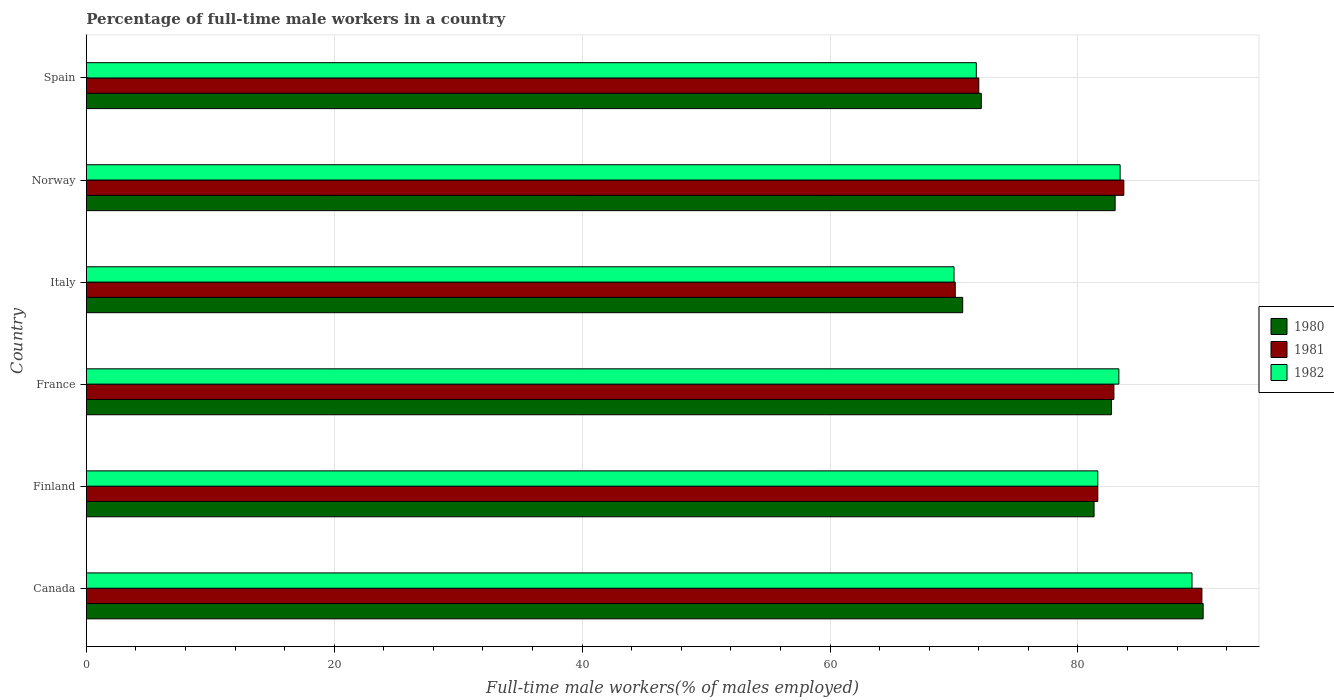How many different coloured bars are there?
Your answer should be very brief. 3. How many groups of bars are there?
Provide a short and direct response. 6. Are the number of bars per tick equal to the number of legend labels?
Provide a short and direct response. Yes. Are the number of bars on each tick of the Y-axis equal?
Offer a terse response. Yes. How many bars are there on the 2nd tick from the top?
Your response must be concise. 3. How many bars are there on the 4th tick from the bottom?
Your response must be concise. 3. What is the label of the 4th group of bars from the top?
Offer a very short reply. France. What is the percentage of full-time male workers in 1981 in France?
Make the answer very short. 82.9. Across all countries, what is the maximum percentage of full-time male workers in 1980?
Provide a short and direct response. 90.1. Across all countries, what is the minimum percentage of full-time male workers in 1980?
Provide a short and direct response. 70.7. In which country was the percentage of full-time male workers in 1982 minimum?
Ensure brevity in your answer.  Italy. What is the total percentage of full-time male workers in 1982 in the graph?
Your response must be concise. 479.3. What is the difference between the percentage of full-time male workers in 1980 in Canada and that in Spain?
Your answer should be compact. 17.9. What is the difference between the percentage of full-time male workers in 1981 in Norway and the percentage of full-time male workers in 1980 in Finland?
Ensure brevity in your answer.  2.4. What is the average percentage of full-time male workers in 1981 per country?
Offer a terse response. 80.05. What is the difference between the percentage of full-time male workers in 1982 and percentage of full-time male workers in 1980 in Spain?
Offer a very short reply. -0.4. What is the ratio of the percentage of full-time male workers in 1981 in France to that in Norway?
Your answer should be compact. 0.99. Is the percentage of full-time male workers in 1982 in Canada less than that in Finland?
Keep it short and to the point. No. What is the difference between the highest and the second highest percentage of full-time male workers in 1981?
Provide a short and direct response. 6.3. What is the difference between the highest and the lowest percentage of full-time male workers in 1982?
Your answer should be very brief. 19.2. In how many countries, is the percentage of full-time male workers in 1980 greater than the average percentage of full-time male workers in 1980 taken over all countries?
Your response must be concise. 4. Is the sum of the percentage of full-time male workers in 1980 in Finland and Spain greater than the maximum percentage of full-time male workers in 1982 across all countries?
Provide a succinct answer. Yes. What does the 3rd bar from the top in Italy represents?
Ensure brevity in your answer.  1980. What does the 2nd bar from the bottom in Italy represents?
Keep it short and to the point. 1981. Are all the bars in the graph horizontal?
Ensure brevity in your answer.  Yes. What is the difference between two consecutive major ticks on the X-axis?
Offer a terse response. 20. Are the values on the major ticks of X-axis written in scientific E-notation?
Your answer should be very brief. No. Where does the legend appear in the graph?
Your response must be concise. Center right. How many legend labels are there?
Your answer should be very brief. 3. How are the legend labels stacked?
Ensure brevity in your answer.  Vertical. What is the title of the graph?
Offer a very short reply. Percentage of full-time male workers in a country. Does "1987" appear as one of the legend labels in the graph?
Give a very brief answer. No. What is the label or title of the X-axis?
Keep it short and to the point. Full-time male workers(% of males employed). What is the Full-time male workers(% of males employed) in 1980 in Canada?
Your answer should be very brief. 90.1. What is the Full-time male workers(% of males employed) of 1982 in Canada?
Provide a succinct answer. 89.2. What is the Full-time male workers(% of males employed) of 1980 in Finland?
Offer a very short reply. 81.3. What is the Full-time male workers(% of males employed) in 1981 in Finland?
Provide a short and direct response. 81.6. What is the Full-time male workers(% of males employed) of 1982 in Finland?
Your response must be concise. 81.6. What is the Full-time male workers(% of males employed) of 1980 in France?
Offer a very short reply. 82.7. What is the Full-time male workers(% of males employed) in 1981 in France?
Offer a very short reply. 82.9. What is the Full-time male workers(% of males employed) of 1982 in France?
Offer a very short reply. 83.3. What is the Full-time male workers(% of males employed) of 1980 in Italy?
Provide a succinct answer. 70.7. What is the Full-time male workers(% of males employed) of 1981 in Italy?
Ensure brevity in your answer.  70.1. What is the Full-time male workers(% of males employed) in 1980 in Norway?
Offer a terse response. 83. What is the Full-time male workers(% of males employed) of 1981 in Norway?
Provide a succinct answer. 83.7. What is the Full-time male workers(% of males employed) in 1982 in Norway?
Your answer should be very brief. 83.4. What is the Full-time male workers(% of males employed) in 1980 in Spain?
Keep it short and to the point. 72.2. What is the Full-time male workers(% of males employed) in 1981 in Spain?
Give a very brief answer. 72. What is the Full-time male workers(% of males employed) in 1982 in Spain?
Provide a short and direct response. 71.8. Across all countries, what is the maximum Full-time male workers(% of males employed) in 1980?
Provide a short and direct response. 90.1. Across all countries, what is the maximum Full-time male workers(% of males employed) in 1982?
Keep it short and to the point. 89.2. Across all countries, what is the minimum Full-time male workers(% of males employed) of 1980?
Offer a terse response. 70.7. Across all countries, what is the minimum Full-time male workers(% of males employed) of 1981?
Your response must be concise. 70.1. Across all countries, what is the minimum Full-time male workers(% of males employed) in 1982?
Offer a very short reply. 70. What is the total Full-time male workers(% of males employed) of 1980 in the graph?
Offer a terse response. 480. What is the total Full-time male workers(% of males employed) in 1981 in the graph?
Keep it short and to the point. 480.3. What is the total Full-time male workers(% of males employed) of 1982 in the graph?
Offer a very short reply. 479.3. What is the difference between the Full-time male workers(% of males employed) in 1980 in Canada and that in Finland?
Your answer should be very brief. 8.8. What is the difference between the Full-time male workers(% of males employed) of 1981 in Canada and that in Finland?
Offer a terse response. 8.4. What is the difference between the Full-time male workers(% of males employed) of 1980 in Canada and that in France?
Offer a terse response. 7.4. What is the difference between the Full-time male workers(% of males employed) in 1982 in Canada and that in France?
Offer a terse response. 5.9. What is the difference between the Full-time male workers(% of males employed) in 1980 in Canada and that in Italy?
Offer a terse response. 19.4. What is the difference between the Full-time male workers(% of males employed) of 1981 in Canada and that in Italy?
Your response must be concise. 19.9. What is the difference between the Full-time male workers(% of males employed) in 1980 in Canada and that in Norway?
Your answer should be very brief. 7.1. What is the difference between the Full-time male workers(% of males employed) in 1982 in Canada and that in Norway?
Your response must be concise. 5.8. What is the difference between the Full-time male workers(% of males employed) of 1980 in Canada and that in Spain?
Keep it short and to the point. 17.9. What is the difference between the Full-time male workers(% of males employed) of 1981 in Canada and that in Spain?
Offer a terse response. 18. What is the difference between the Full-time male workers(% of males employed) of 1982 in Finland and that in France?
Make the answer very short. -1.7. What is the difference between the Full-time male workers(% of males employed) of 1980 in Finland and that in Italy?
Offer a terse response. 10.6. What is the difference between the Full-time male workers(% of males employed) in 1981 in Finland and that in Italy?
Offer a very short reply. 11.5. What is the difference between the Full-time male workers(% of males employed) in 1980 in Finland and that in Norway?
Your answer should be very brief. -1.7. What is the difference between the Full-time male workers(% of males employed) of 1981 in Finland and that in Norway?
Your answer should be very brief. -2.1. What is the difference between the Full-time male workers(% of males employed) in 1980 in France and that in Norway?
Provide a succinct answer. -0.3. What is the difference between the Full-time male workers(% of males employed) in 1981 in France and that in Norway?
Provide a succinct answer. -0.8. What is the difference between the Full-time male workers(% of males employed) in 1982 in France and that in Spain?
Offer a very short reply. 11.5. What is the difference between the Full-time male workers(% of males employed) in 1981 in Italy and that in Norway?
Provide a succinct answer. -13.6. What is the difference between the Full-time male workers(% of males employed) in 1982 in Italy and that in Norway?
Give a very brief answer. -13.4. What is the difference between the Full-time male workers(% of males employed) of 1981 in Italy and that in Spain?
Your answer should be compact. -1.9. What is the difference between the Full-time male workers(% of males employed) of 1980 in Norway and that in Spain?
Your answer should be very brief. 10.8. What is the difference between the Full-time male workers(% of males employed) in 1981 in Norway and that in Spain?
Ensure brevity in your answer.  11.7. What is the difference between the Full-time male workers(% of males employed) of 1982 in Norway and that in Spain?
Give a very brief answer. 11.6. What is the difference between the Full-time male workers(% of males employed) in 1980 in Canada and the Full-time male workers(% of males employed) in 1981 in Finland?
Your response must be concise. 8.5. What is the difference between the Full-time male workers(% of males employed) of 1981 in Canada and the Full-time male workers(% of males employed) of 1982 in Finland?
Make the answer very short. 8.4. What is the difference between the Full-time male workers(% of males employed) of 1980 in Canada and the Full-time male workers(% of males employed) of 1981 in France?
Make the answer very short. 7.2. What is the difference between the Full-time male workers(% of males employed) in 1981 in Canada and the Full-time male workers(% of males employed) in 1982 in France?
Your answer should be compact. 6.7. What is the difference between the Full-time male workers(% of males employed) of 1980 in Canada and the Full-time male workers(% of males employed) of 1981 in Italy?
Your response must be concise. 20. What is the difference between the Full-time male workers(% of males employed) in 1980 in Canada and the Full-time male workers(% of males employed) in 1982 in Italy?
Your answer should be very brief. 20.1. What is the difference between the Full-time male workers(% of males employed) of 1981 in Canada and the Full-time male workers(% of males employed) of 1982 in Norway?
Offer a terse response. 6.6. What is the difference between the Full-time male workers(% of males employed) in 1980 in Finland and the Full-time male workers(% of males employed) in 1981 in France?
Your answer should be very brief. -1.6. What is the difference between the Full-time male workers(% of males employed) of 1980 in Finland and the Full-time male workers(% of males employed) of 1982 in France?
Make the answer very short. -2. What is the difference between the Full-time male workers(% of males employed) of 1981 in Finland and the Full-time male workers(% of males employed) of 1982 in France?
Offer a terse response. -1.7. What is the difference between the Full-time male workers(% of males employed) in 1981 in Finland and the Full-time male workers(% of males employed) in 1982 in Italy?
Offer a terse response. 11.6. What is the difference between the Full-time male workers(% of males employed) of 1980 in Finland and the Full-time male workers(% of males employed) of 1981 in Norway?
Offer a very short reply. -2.4. What is the difference between the Full-time male workers(% of males employed) in 1981 in Finland and the Full-time male workers(% of males employed) in 1982 in Norway?
Ensure brevity in your answer.  -1.8. What is the difference between the Full-time male workers(% of males employed) in 1980 in Finland and the Full-time male workers(% of males employed) in 1981 in Spain?
Ensure brevity in your answer.  9.3. What is the difference between the Full-time male workers(% of males employed) of 1981 in Finland and the Full-time male workers(% of males employed) of 1982 in Spain?
Your answer should be very brief. 9.8. What is the difference between the Full-time male workers(% of males employed) in 1980 in France and the Full-time male workers(% of males employed) in 1982 in Italy?
Your answer should be very brief. 12.7. What is the difference between the Full-time male workers(% of males employed) in 1980 in France and the Full-time male workers(% of males employed) in 1981 in Norway?
Provide a short and direct response. -1. What is the difference between the Full-time male workers(% of males employed) of 1980 in Italy and the Full-time male workers(% of males employed) of 1981 in Norway?
Give a very brief answer. -13. What is the difference between the Full-time male workers(% of males employed) in 1980 in Norway and the Full-time male workers(% of males employed) in 1981 in Spain?
Provide a short and direct response. 11. What is the difference between the Full-time male workers(% of males employed) of 1980 in Norway and the Full-time male workers(% of males employed) of 1982 in Spain?
Your answer should be compact. 11.2. What is the difference between the Full-time male workers(% of males employed) of 1981 in Norway and the Full-time male workers(% of males employed) of 1982 in Spain?
Your answer should be very brief. 11.9. What is the average Full-time male workers(% of males employed) in 1981 per country?
Your answer should be compact. 80.05. What is the average Full-time male workers(% of males employed) in 1982 per country?
Offer a terse response. 79.88. What is the difference between the Full-time male workers(% of males employed) in 1980 and Full-time male workers(% of males employed) in 1982 in France?
Keep it short and to the point. -0.6. What is the difference between the Full-time male workers(% of males employed) of 1981 and Full-time male workers(% of males employed) of 1982 in France?
Offer a very short reply. -0.4. What is the difference between the Full-time male workers(% of males employed) in 1980 and Full-time male workers(% of males employed) in 1981 in Italy?
Offer a terse response. 0.6. What is the difference between the Full-time male workers(% of males employed) in 1980 and Full-time male workers(% of males employed) in 1982 in Italy?
Provide a succinct answer. 0.7. What is the difference between the Full-time male workers(% of males employed) of 1980 and Full-time male workers(% of males employed) of 1981 in Norway?
Your answer should be very brief. -0.7. What is the difference between the Full-time male workers(% of males employed) of 1980 and Full-time male workers(% of males employed) of 1982 in Norway?
Provide a short and direct response. -0.4. What is the difference between the Full-time male workers(% of males employed) of 1981 and Full-time male workers(% of males employed) of 1982 in Norway?
Your answer should be compact. 0.3. What is the difference between the Full-time male workers(% of males employed) in 1980 and Full-time male workers(% of males employed) in 1981 in Spain?
Provide a short and direct response. 0.2. What is the difference between the Full-time male workers(% of males employed) of 1981 and Full-time male workers(% of males employed) of 1982 in Spain?
Make the answer very short. 0.2. What is the ratio of the Full-time male workers(% of males employed) of 1980 in Canada to that in Finland?
Your answer should be very brief. 1.11. What is the ratio of the Full-time male workers(% of males employed) in 1981 in Canada to that in Finland?
Provide a succinct answer. 1.1. What is the ratio of the Full-time male workers(% of males employed) of 1982 in Canada to that in Finland?
Your answer should be compact. 1.09. What is the ratio of the Full-time male workers(% of males employed) of 1980 in Canada to that in France?
Provide a succinct answer. 1.09. What is the ratio of the Full-time male workers(% of males employed) of 1981 in Canada to that in France?
Your answer should be very brief. 1.09. What is the ratio of the Full-time male workers(% of males employed) in 1982 in Canada to that in France?
Provide a short and direct response. 1.07. What is the ratio of the Full-time male workers(% of males employed) in 1980 in Canada to that in Italy?
Your answer should be compact. 1.27. What is the ratio of the Full-time male workers(% of males employed) of 1981 in Canada to that in Italy?
Give a very brief answer. 1.28. What is the ratio of the Full-time male workers(% of males employed) in 1982 in Canada to that in Italy?
Offer a terse response. 1.27. What is the ratio of the Full-time male workers(% of males employed) of 1980 in Canada to that in Norway?
Give a very brief answer. 1.09. What is the ratio of the Full-time male workers(% of males employed) in 1981 in Canada to that in Norway?
Keep it short and to the point. 1.08. What is the ratio of the Full-time male workers(% of males employed) in 1982 in Canada to that in Norway?
Keep it short and to the point. 1.07. What is the ratio of the Full-time male workers(% of males employed) in 1980 in Canada to that in Spain?
Give a very brief answer. 1.25. What is the ratio of the Full-time male workers(% of males employed) in 1981 in Canada to that in Spain?
Your answer should be compact. 1.25. What is the ratio of the Full-time male workers(% of males employed) in 1982 in Canada to that in Spain?
Your answer should be compact. 1.24. What is the ratio of the Full-time male workers(% of males employed) of 1980 in Finland to that in France?
Your answer should be compact. 0.98. What is the ratio of the Full-time male workers(% of males employed) in 1981 in Finland to that in France?
Your response must be concise. 0.98. What is the ratio of the Full-time male workers(% of males employed) of 1982 in Finland to that in France?
Give a very brief answer. 0.98. What is the ratio of the Full-time male workers(% of males employed) of 1980 in Finland to that in Italy?
Make the answer very short. 1.15. What is the ratio of the Full-time male workers(% of males employed) in 1981 in Finland to that in Italy?
Keep it short and to the point. 1.16. What is the ratio of the Full-time male workers(% of males employed) of 1982 in Finland to that in Italy?
Your answer should be very brief. 1.17. What is the ratio of the Full-time male workers(% of males employed) in 1980 in Finland to that in Norway?
Keep it short and to the point. 0.98. What is the ratio of the Full-time male workers(% of males employed) of 1981 in Finland to that in Norway?
Make the answer very short. 0.97. What is the ratio of the Full-time male workers(% of males employed) of 1982 in Finland to that in Norway?
Give a very brief answer. 0.98. What is the ratio of the Full-time male workers(% of males employed) of 1980 in Finland to that in Spain?
Give a very brief answer. 1.13. What is the ratio of the Full-time male workers(% of males employed) in 1981 in Finland to that in Spain?
Make the answer very short. 1.13. What is the ratio of the Full-time male workers(% of males employed) in 1982 in Finland to that in Spain?
Offer a very short reply. 1.14. What is the ratio of the Full-time male workers(% of males employed) of 1980 in France to that in Italy?
Ensure brevity in your answer.  1.17. What is the ratio of the Full-time male workers(% of males employed) in 1981 in France to that in Italy?
Ensure brevity in your answer.  1.18. What is the ratio of the Full-time male workers(% of males employed) of 1982 in France to that in Italy?
Make the answer very short. 1.19. What is the ratio of the Full-time male workers(% of males employed) of 1980 in France to that in Norway?
Provide a short and direct response. 1. What is the ratio of the Full-time male workers(% of males employed) of 1981 in France to that in Norway?
Make the answer very short. 0.99. What is the ratio of the Full-time male workers(% of males employed) in 1982 in France to that in Norway?
Your answer should be compact. 1. What is the ratio of the Full-time male workers(% of males employed) of 1980 in France to that in Spain?
Offer a very short reply. 1.15. What is the ratio of the Full-time male workers(% of males employed) in 1981 in France to that in Spain?
Offer a very short reply. 1.15. What is the ratio of the Full-time male workers(% of males employed) of 1982 in France to that in Spain?
Your response must be concise. 1.16. What is the ratio of the Full-time male workers(% of males employed) of 1980 in Italy to that in Norway?
Give a very brief answer. 0.85. What is the ratio of the Full-time male workers(% of males employed) in 1981 in Italy to that in Norway?
Provide a short and direct response. 0.84. What is the ratio of the Full-time male workers(% of males employed) in 1982 in Italy to that in Norway?
Offer a very short reply. 0.84. What is the ratio of the Full-time male workers(% of males employed) of 1980 in Italy to that in Spain?
Provide a short and direct response. 0.98. What is the ratio of the Full-time male workers(% of males employed) of 1981 in Italy to that in Spain?
Offer a very short reply. 0.97. What is the ratio of the Full-time male workers(% of males employed) in 1982 in Italy to that in Spain?
Ensure brevity in your answer.  0.97. What is the ratio of the Full-time male workers(% of males employed) of 1980 in Norway to that in Spain?
Your answer should be very brief. 1.15. What is the ratio of the Full-time male workers(% of males employed) of 1981 in Norway to that in Spain?
Offer a terse response. 1.16. What is the ratio of the Full-time male workers(% of males employed) of 1982 in Norway to that in Spain?
Your answer should be very brief. 1.16. What is the difference between the highest and the second highest Full-time male workers(% of males employed) in 1981?
Offer a very short reply. 6.3. What is the difference between the highest and the lowest Full-time male workers(% of males employed) of 1980?
Keep it short and to the point. 19.4. What is the difference between the highest and the lowest Full-time male workers(% of males employed) in 1981?
Make the answer very short. 19.9. 